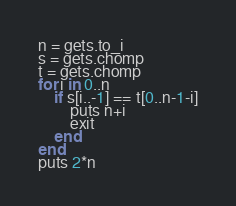Convert code to text. <code><loc_0><loc_0><loc_500><loc_500><_Ruby_>n = gets.to_i
s = gets.chomp
t = gets.chomp
for i in 0..n
    if s[i..-1] == t[0..n-1-i]
        puts n+i
        exit
    end
end
puts 2*n</code> 